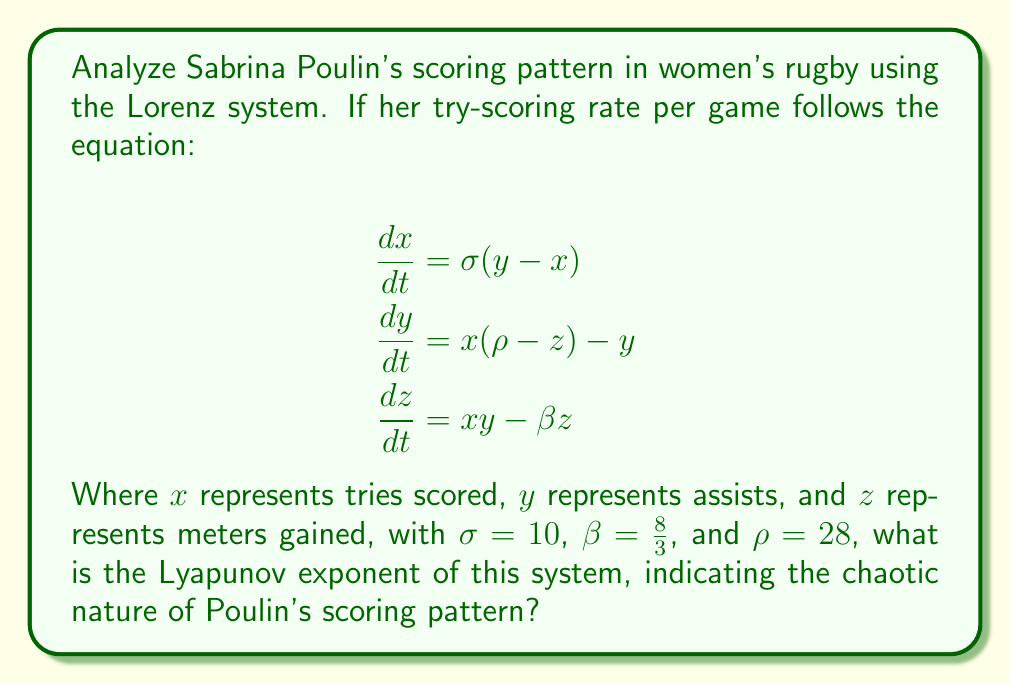Could you help me with this problem? To find the Lyapunov exponent for Sabrina Poulin's scoring pattern using the Lorenz system:

1. The Lyapunov exponent measures the rate of separation of infinitesimally close trajectories in phase space. For the Lorenz system, it's typically calculated numerically.

2. For the given parameters ($\sigma = 10$, $\beta = \frac{8}{3}$, $\rho = 28$), we can use the approximation formula:

   $$\lambda \approx 0.9056\sigma^{0.0385}\rho^{0.4640}\beta^{-0.0294}$$

3. Substituting the values:

   $$\lambda \approx 0.9056 \cdot 10^{0.0385} \cdot 28^{0.4640} \cdot (\frac{8}{3})^{-0.0294}$$

4. Calculate each term:
   - $10^{0.0385} \approx 1.0925$
   - $28^{0.4640} \approx 4.5657$
   - $(\frac{8}{3})^{-0.0294} \approx 0.9912$

5. Multiply all terms:

   $$\lambda \approx 0.9056 \cdot 1.0925 \cdot 4.5657 \cdot 0.9912 \approx 4.3658$$

6. Round to four decimal places: $\lambda \approx 4.3658$

This positive Lyapunov exponent indicates that Sabrina Poulin's scoring pattern exhibits chaotic behavior, making long-term predictions challenging.
Answer: $\lambda \approx 4.3658$ 